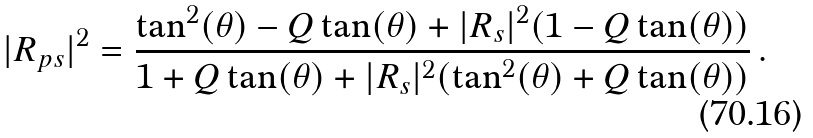<formula> <loc_0><loc_0><loc_500><loc_500>| R _ { p s } | ^ { 2 } = \frac { \tan ^ { 2 } ( \theta ) - Q \tan ( \theta ) + | R _ { s } | ^ { 2 } ( 1 - Q \tan ( \theta ) ) } { 1 + Q \tan ( \theta ) + | R _ { s } | ^ { 2 } ( \tan ^ { 2 } ( \theta ) + Q \tan ( \theta ) ) } \, .</formula> 